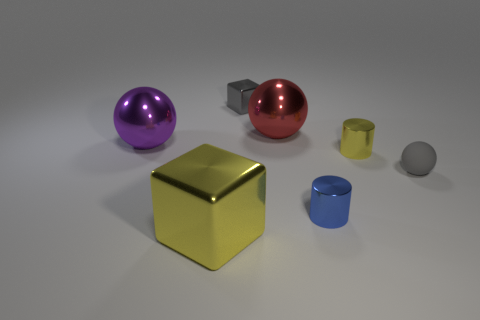Add 1 large red things. How many objects exist? 8 Subtract all balls. How many objects are left? 4 Subtract all purple objects. Subtract all red metallic spheres. How many objects are left? 5 Add 4 metallic spheres. How many metallic spheres are left? 6 Add 2 big gray rubber balls. How many big gray rubber balls exist? 2 Subtract 0 green balls. How many objects are left? 7 